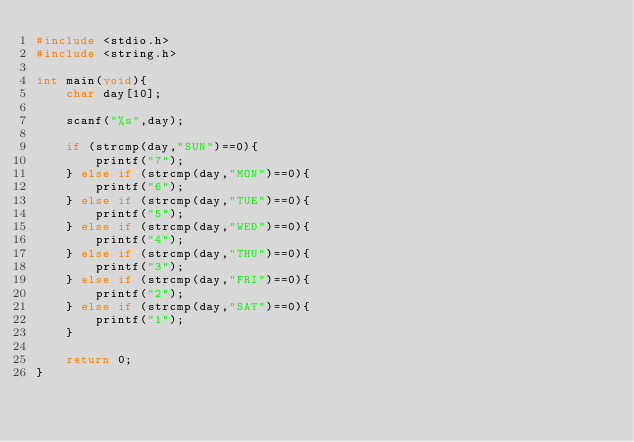<code> <loc_0><loc_0><loc_500><loc_500><_C_>#include <stdio.h>
#include <string.h>

int main(void){
    char day[10];
    
    scanf("%s",day);
    
    if (strcmp(day,"SUN")==0){
        printf("7");
    } else if (strcmp(day,"MON")==0){
        printf("6");
    } else if (strcmp(day,"TUE")==0){
        printf("5");
    } else if (strcmp(day,"WED")==0){
        printf("4");
    } else if (strcmp(day,"THU")==0){
        printf("3");
    } else if (strcmp(day,"FRI")==0){
        printf("2");
    } else if (strcmp(day,"SAT")==0){
        printf("1");
    }
    
    return 0;
}
</code> 